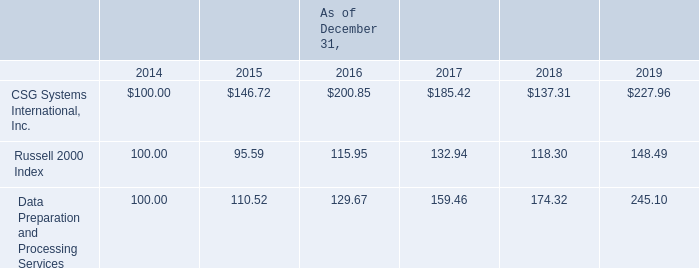Item 5. Market for Registrant’s Common Equity, Related Stockholder Matters and Issuer Purchases of Equity Securities
Our common stock is listed on NASDAQ under the symbol ‘‘CSGS’’. On January 31, 2020, the number of holders of record of common stock was 126.
Stock Price Performance
The following graph compares the cumulative total stockholder return on our common stock, the Russell 2000 Index, and our Standard Industrial Classification (“SIC”) Code Index: Data Preparation and Processing Services during the indicated five-year period. The graph assumes that $100 was invested on December 31, 2014, in our common stock and in each of the two indexes, and that all dividends, if any, were reinvested.
How many common stock shareholders does the company have on January 31, 2020? 126. What symbol is the company's common stock listed under on NASDAQ? Csgs. As of December 2019, which is the best performing stock? Data preparation and processing services. Which stock enjoyed year on year growth between 2014 to 2019? Data preparation and processing services. Between CSG Systems International, Inc and Russell 2000 Index, which performed better in the year 2015? 146.72 > 95.59
Answer: csg systems international, inc. What is the cumulative total stockholder return of Russell 2000 Index as of 31 December, 2018? 118.30. 